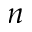Convert formula to latex. <formula><loc_0><loc_0><loc_500><loc_500>n</formula> 